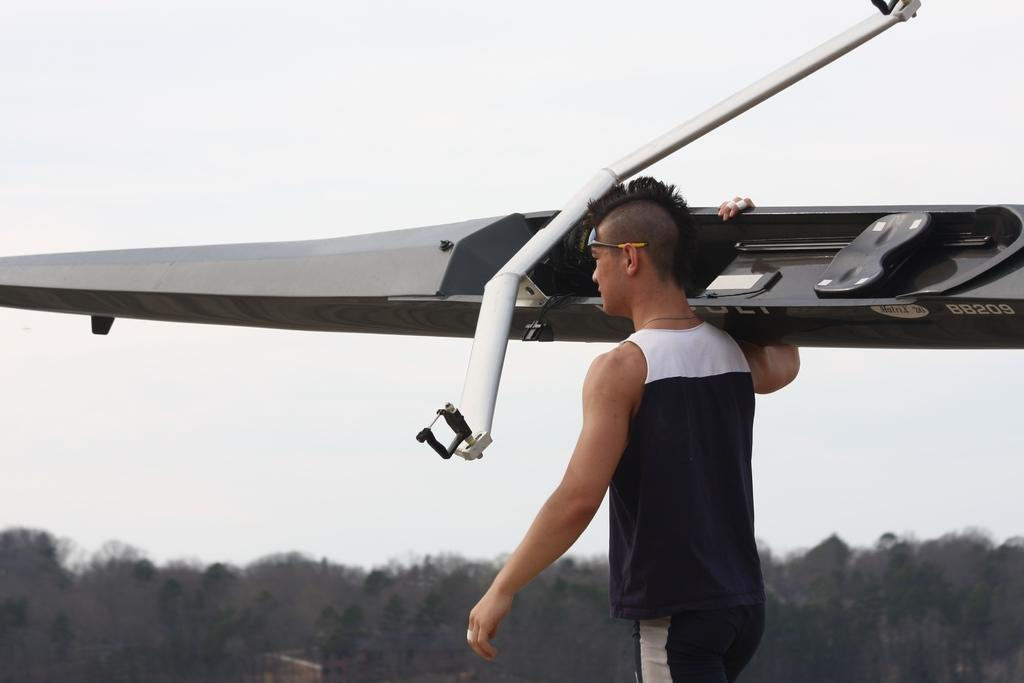Provide a one-sentence caption for the provided image. The Matrix 26 glider's identification number is BB209. 